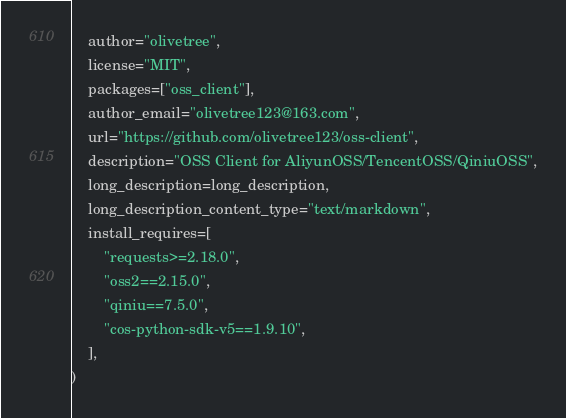<code> <loc_0><loc_0><loc_500><loc_500><_Python_>    author="olivetree",
    license="MIT",
    packages=["oss_client"],
    author_email="olivetree123@163.com",
    url="https://github.com/olivetree123/oss-client",
    description="OSS Client for AliyunOSS/TencentOSS/QiniuOSS",
    long_description=long_description,
    long_description_content_type="text/markdown",
    install_requires=[
        "requests>=2.18.0",
        "oss2==2.15.0",
        "qiniu==7.5.0",
        "cos-python-sdk-v5==1.9.10",
    ],
)
</code> 